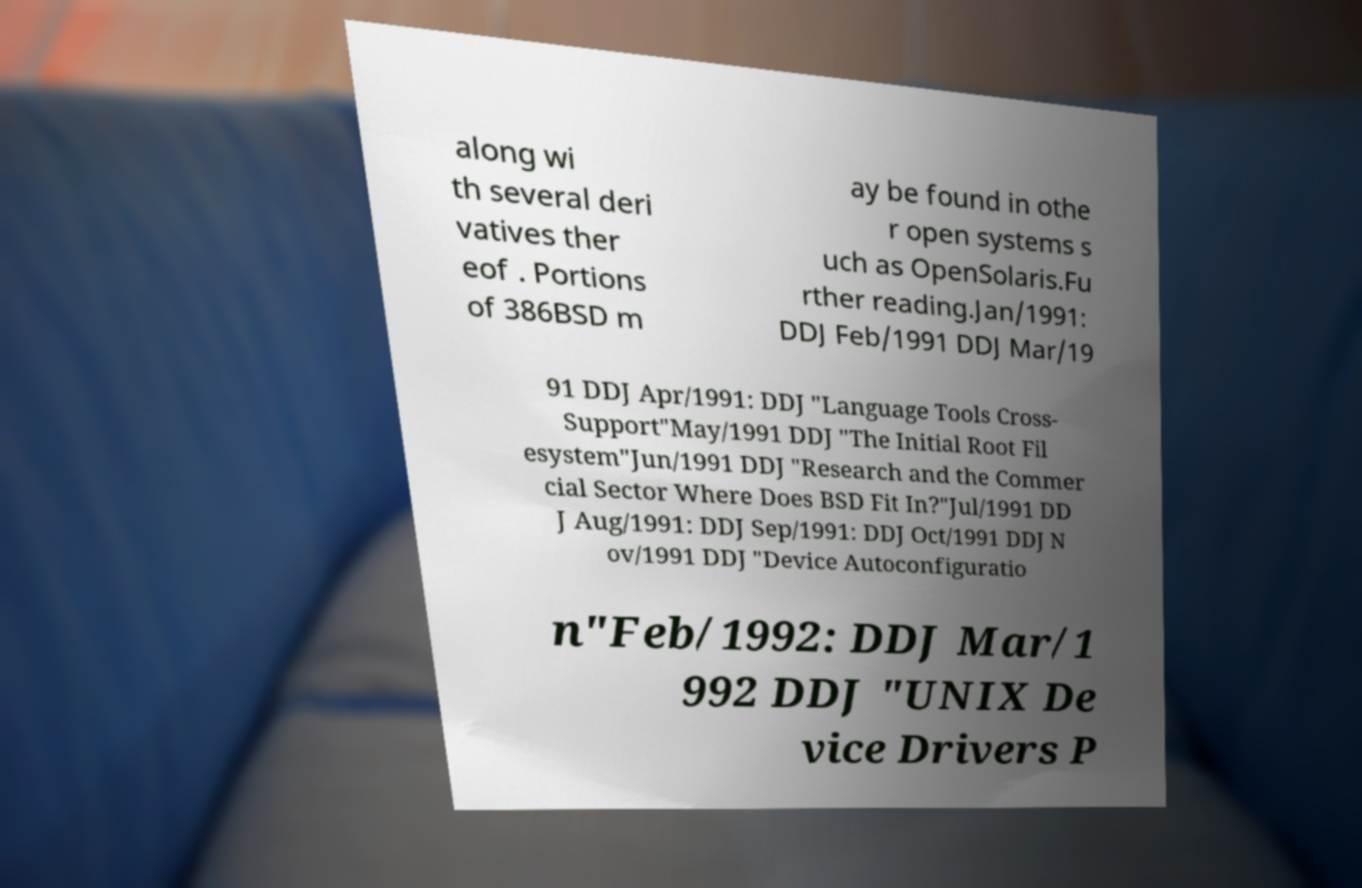For documentation purposes, I need the text within this image transcribed. Could you provide that? along wi th several deri vatives ther eof . Portions of 386BSD m ay be found in othe r open systems s uch as OpenSolaris.Fu rther reading.Jan/1991: DDJ Feb/1991 DDJ Mar/19 91 DDJ Apr/1991: DDJ "Language Tools Cross- Support"May/1991 DDJ "The Initial Root Fil esystem"Jun/1991 DDJ "Research and the Commer cial Sector Where Does BSD Fit In?"Jul/1991 DD J Aug/1991: DDJ Sep/1991: DDJ Oct/1991 DDJ N ov/1991 DDJ "Device Autoconfiguratio n"Feb/1992: DDJ Mar/1 992 DDJ "UNIX De vice Drivers P 